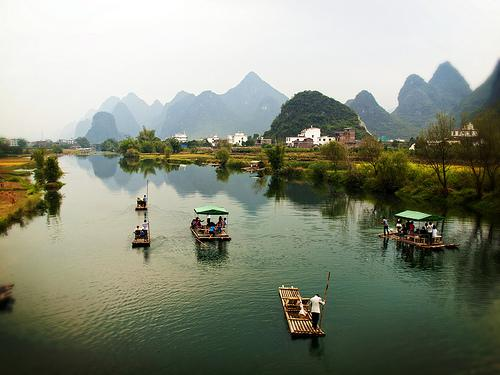Question: who is taking the picture?
Choices:
A. A photographer.
B. Mother of the bride.
C. Sister of the groom.
D. Aunt.
Answer with the letter. Answer: A Question: what is the water reflecting?
Choices:
A. Sun.
B. Trees.
C. A boat.
D. The mountains.
Answer with the letter. Answer: D Question: how many boats are on the water?
Choices:
A. 7 boats are in the water.
B. 8 boats are in the water.
C. 5 boats in the water.
D. 3 boats are in the water.
Answer with the letter. Answer: C Question: what color are the trees?
Choices:
A. The trees are green.
B. The trees are brown.
C. The trees are yellow.
D. The trees are black.
Answer with the letter. Answer: A 